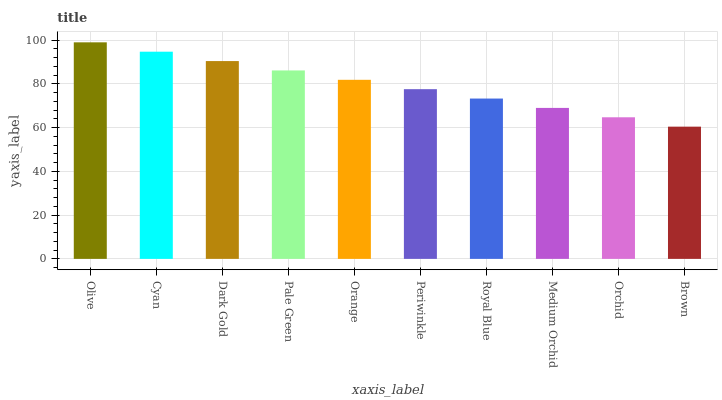Is Cyan the minimum?
Answer yes or no. No. Is Cyan the maximum?
Answer yes or no. No. Is Olive greater than Cyan?
Answer yes or no. Yes. Is Cyan less than Olive?
Answer yes or no. Yes. Is Cyan greater than Olive?
Answer yes or no. No. Is Olive less than Cyan?
Answer yes or no. No. Is Orange the high median?
Answer yes or no. Yes. Is Periwinkle the low median?
Answer yes or no. Yes. Is Dark Gold the high median?
Answer yes or no. No. Is Cyan the low median?
Answer yes or no. No. 